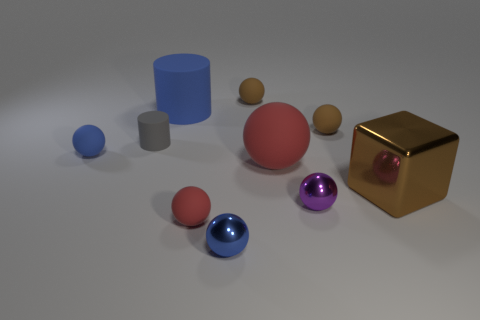Subtract all red spheres. How many spheres are left? 5 Subtract all tiny red matte spheres. How many spheres are left? 6 Subtract all green balls. Subtract all red cylinders. How many balls are left? 7 Subtract all cubes. How many objects are left? 9 Subtract 0 gray balls. How many objects are left? 10 Subtract all red matte spheres. Subtract all small gray cylinders. How many objects are left? 7 Add 5 blue metal balls. How many blue metal balls are left? 6 Add 1 small rubber things. How many small rubber things exist? 6 